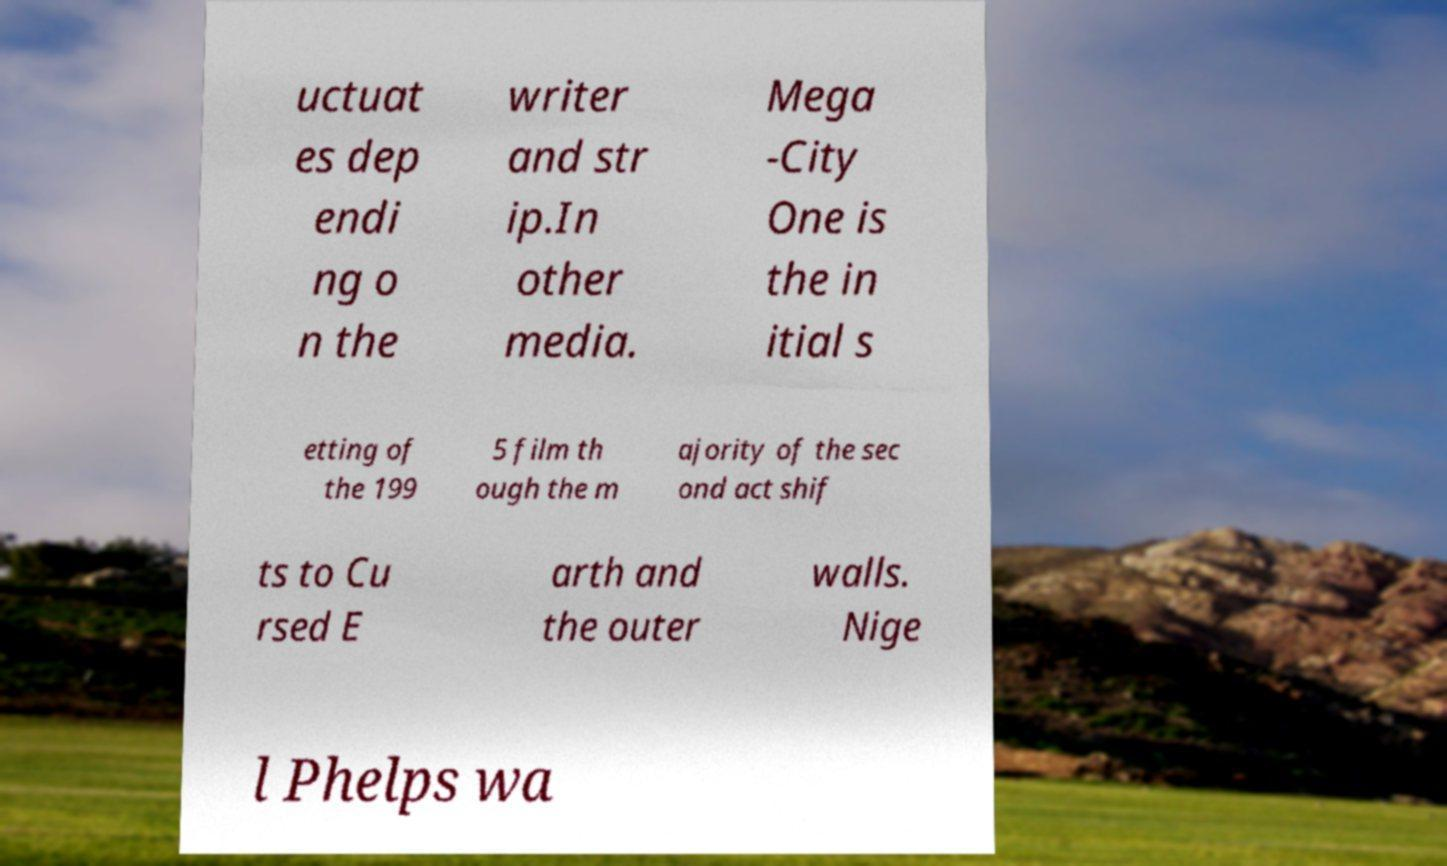Could you assist in decoding the text presented in this image and type it out clearly? uctuat es dep endi ng o n the writer and str ip.In other media. Mega -City One is the in itial s etting of the 199 5 film th ough the m ajority of the sec ond act shif ts to Cu rsed E arth and the outer walls. Nige l Phelps wa 